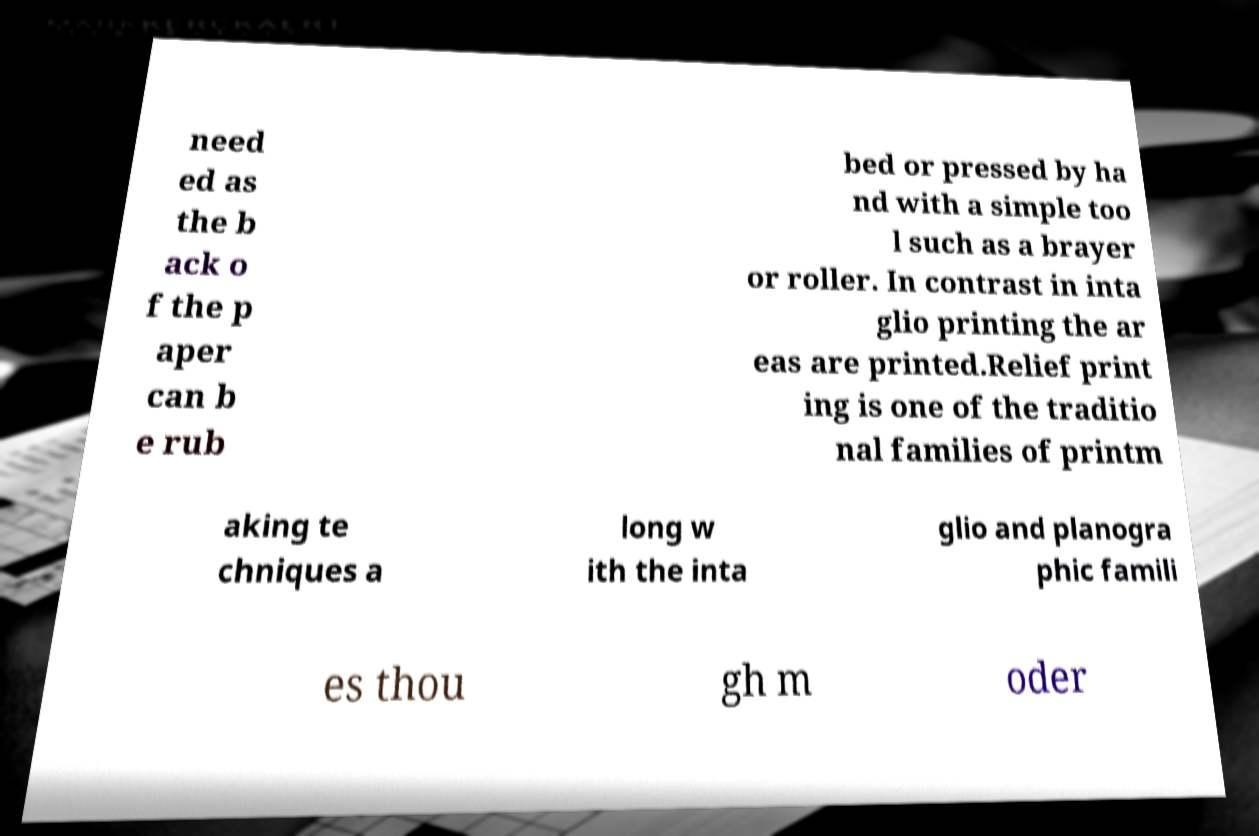Could you assist in decoding the text presented in this image and type it out clearly? need ed as the b ack o f the p aper can b e rub bed or pressed by ha nd with a simple too l such as a brayer or roller. In contrast in inta glio printing the ar eas are printed.Relief print ing is one of the traditio nal families of printm aking te chniques a long w ith the inta glio and planogra phic famili es thou gh m oder 